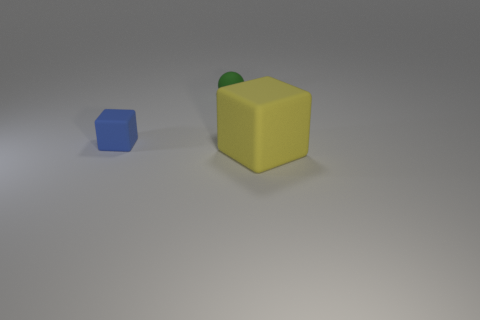There is a big matte object that is in front of the matte sphere; is its shape the same as the blue object?
Provide a succinct answer. Yes. There is a small thing that is the same shape as the big rubber object; what color is it?
Offer a very short reply. Blue. Is there anything else that is the same shape as the big yellow rubber object?
Your response must be concise. Yes. Are there an equal number of blocks right of the blue cube and big yellow rubber blocks?
Offer a very short reply. Yes. How many things are in front of the blue matte cube and behind the small blue matte thing?
Ensure brevity in your answer.  0. The other matte object that is the same shape as the tiny blue thing is what size?
Make the answer very short. Large. How many other things are made of the same material as the green thing?
Provide a short and direct response. 2. Are there fewer small green spheres that are right of the blue thing than tiny rubber objects?
Provide a short and direct response. Yes. What number of large metallic cubes are there?
Offer a very short reply. 0. What number of blocks have the same color as the sphere?
Your response must be concise. 0. 